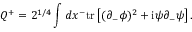Convert formula to latex. <formula><loc_0><loc_0><loc_500><loc_500>Q ^ { + } = 2 ^ { 1 / 4 } \int d x ^ { - } t r \left [ ( \partial _ { - } \phi ) ^ { 2 } + i \psi \partial _ { - } \psi \right ] .</formula> 